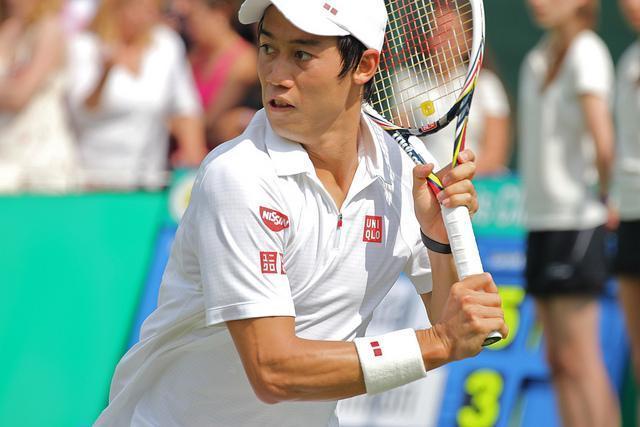How many people are there?
Give a very brief answer. 7. 